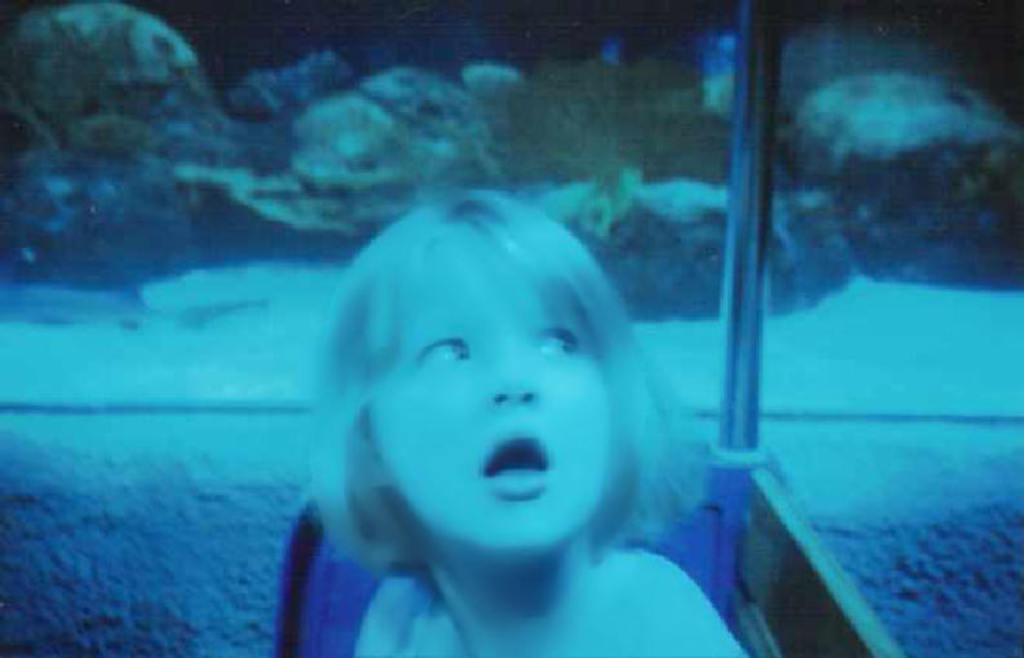Can you describe this image briefly? In this image we can see a girl. Also there is a pole. In the back there is water. Also there are rocks. 